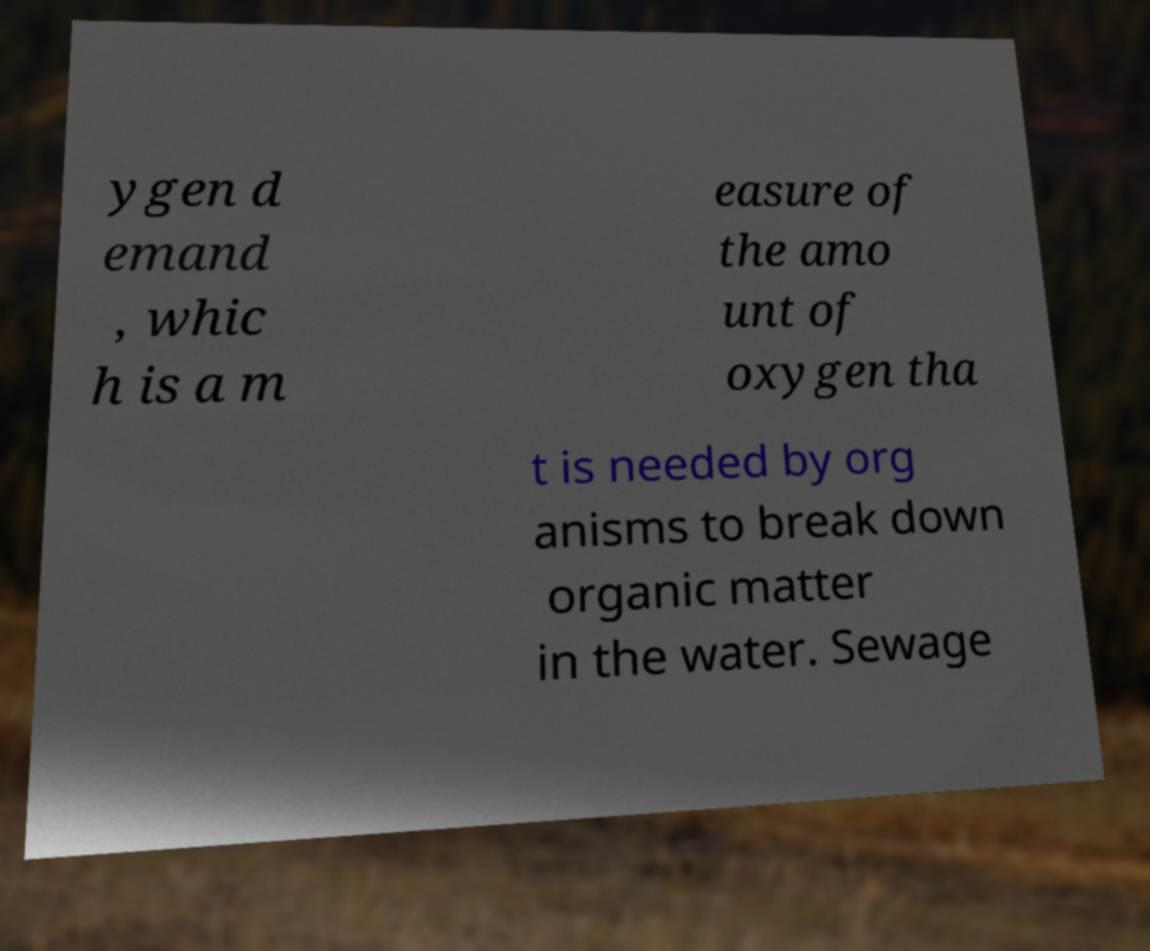Please identify and transcribe the text found in this image. ygen d emand , whic h is a m easure of the amo unt of oxygen tha t is needed by org anisms to break down organic matter in the water. Sewage 